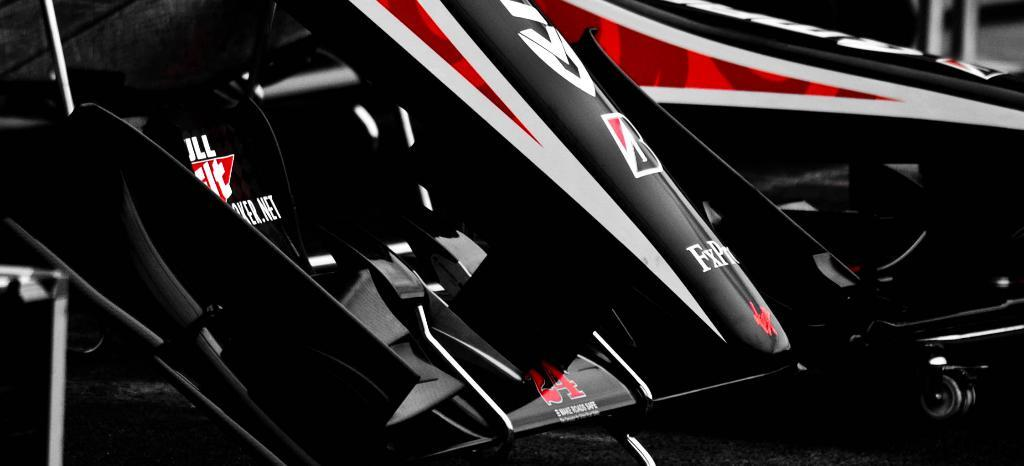What type of vehicle is in the image? There is a sports car in the image. What part of the sports car is visible in the center of the image? The front bumper of the sports car is visible in the center of the image. What is written or displayed on the front bumper? There is text on the front bumper. How would you describe the background of the image? The background of the image is blurred. Where is the crow perched on the sports car in the image? There is no crow present in the image. What type of faucet is installed in the sports car in the image? There is no faucet present in the sports car in the image. 